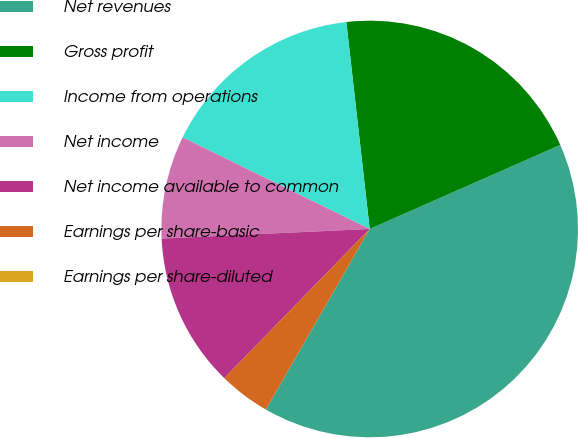Convert chart to OTSL. <chart><loc_0><loc_0><loc_500><loc_500><pie_chart><fcel>Net revenues<fcel>Gross profit<fcel>Income from operations<fcel>Net income<fcel>Net income available to common<fcel>Earnings per share-basic<fcel>Earnings per share-diluted<nl><fcel>39.91%<fcel>20.18%<fcel>15.96%<fcel>7.98%<fcel>11.97%<fcel>3.99%<fcel>0.0%<nl></chart> 